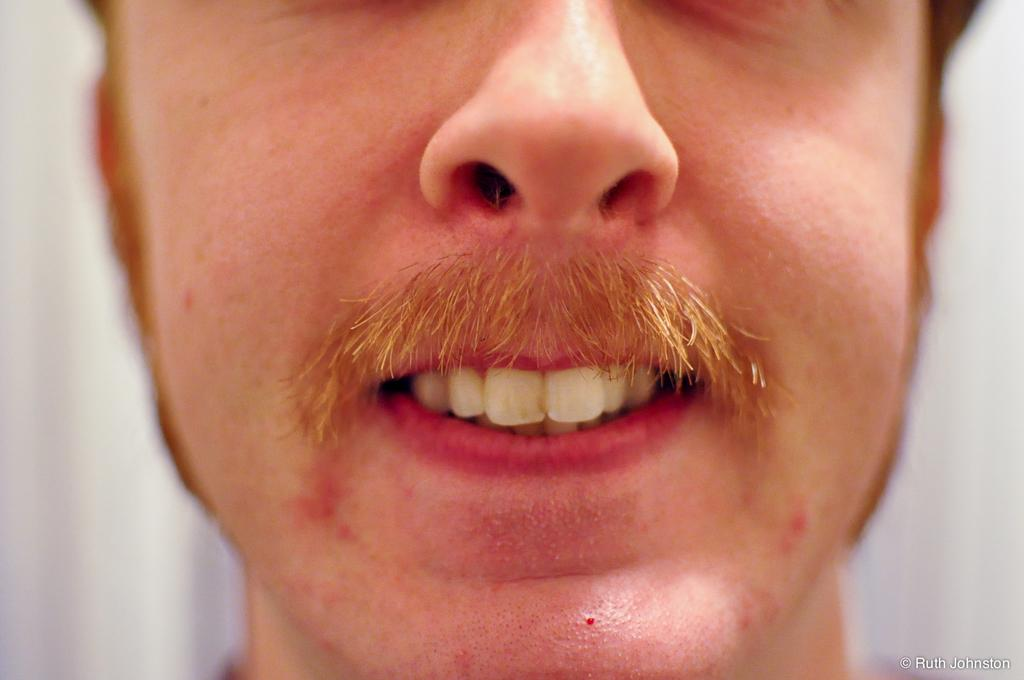What is the color of the background in the image? The background of the image is white. What is the main subject of the image? There is a face of a man in the middle of the image. What facial feature can be seen on the man's face? The man's face has a nose. What additional facial feature does the man have? The man has a mustache. What is another facial feature visible on the man's face? The man's face has a mouth. What can be seen inside the man's mouth? The man's mouth has teeth. Can you see any fog in the image? There is no fog present in the image; it features a man's face with a white background. 